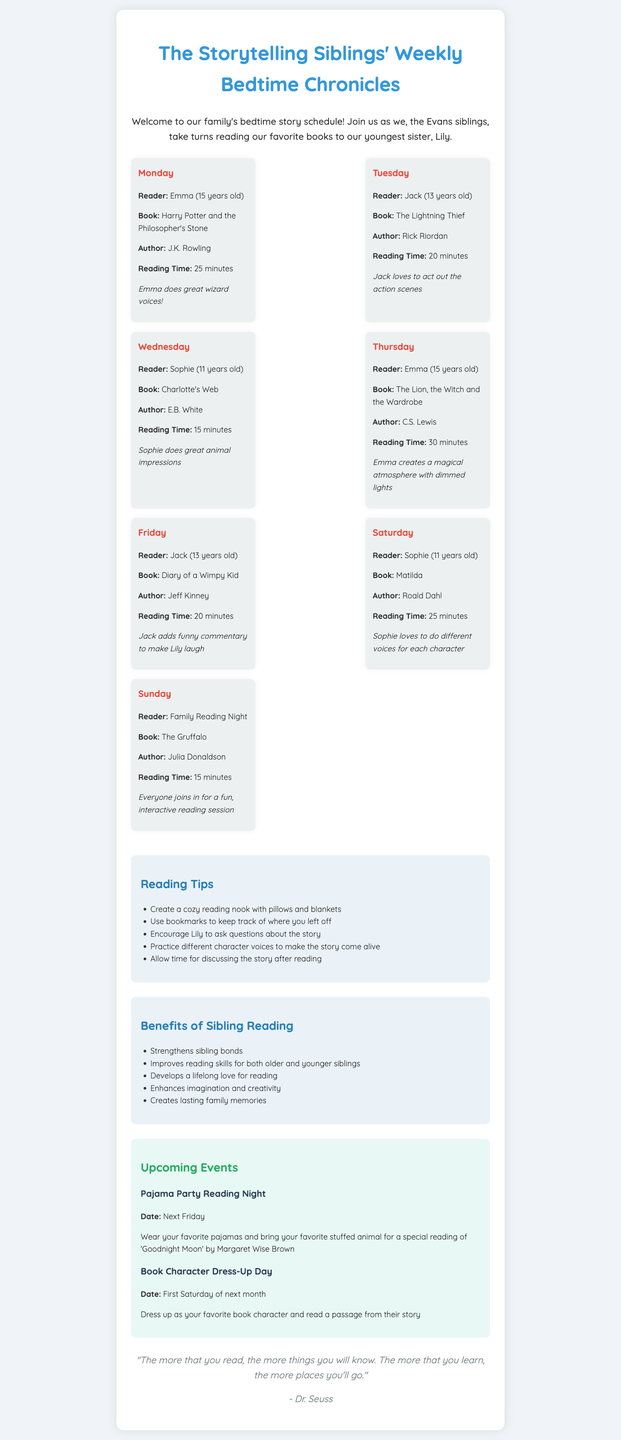what is the title of the newsletter? The title of the newsletter is the main heading that represents the content, which is "The Storytelling Siblings' Weekly Bedtime Chronicles."
Answer: The Storytelling Siblings' Weekly Bedtime Chronicles who reads on Wednesday? This asks for the name of the sibling who reads on Wednesday, which is specified in the schedule.
Answer: Sophie how long is the reading time for "The Lion, the Witch and the Wardrobe"? This question asks for the estimated reading time stated in the schedule for a specific book.
Answer: 30 minutes what special talent does Emma have when reading? This is seeking specific information about a special note for Emma's reading sessions.
Answer: Emma does great wizard voices! how many books does Sophie read during the week? This requires counting how many times Sophie is listed as the reader in the schedule.
Answer: 2 books what is the date of the upcoming Pajama Party Reading Night? The question focuses on extracting the specific date mentioned for the upcoming event in the events section.
Answer: Next Friday what are the benefits of sibling reading according to the newsletter? This asks about the advantages outlined in the document regarding siblings reading together.
Answer: Strengthens sibling bonds what is encouraged after reading the stories? This question seeks to identify an activity that should occur following the reading sessions as suggested in the tips.
Answer: Discussing the story who participates in the Sunday reading session? This inquires about the reader or participants specified for the Sunday reading night in the schedule.
Answer: Family 